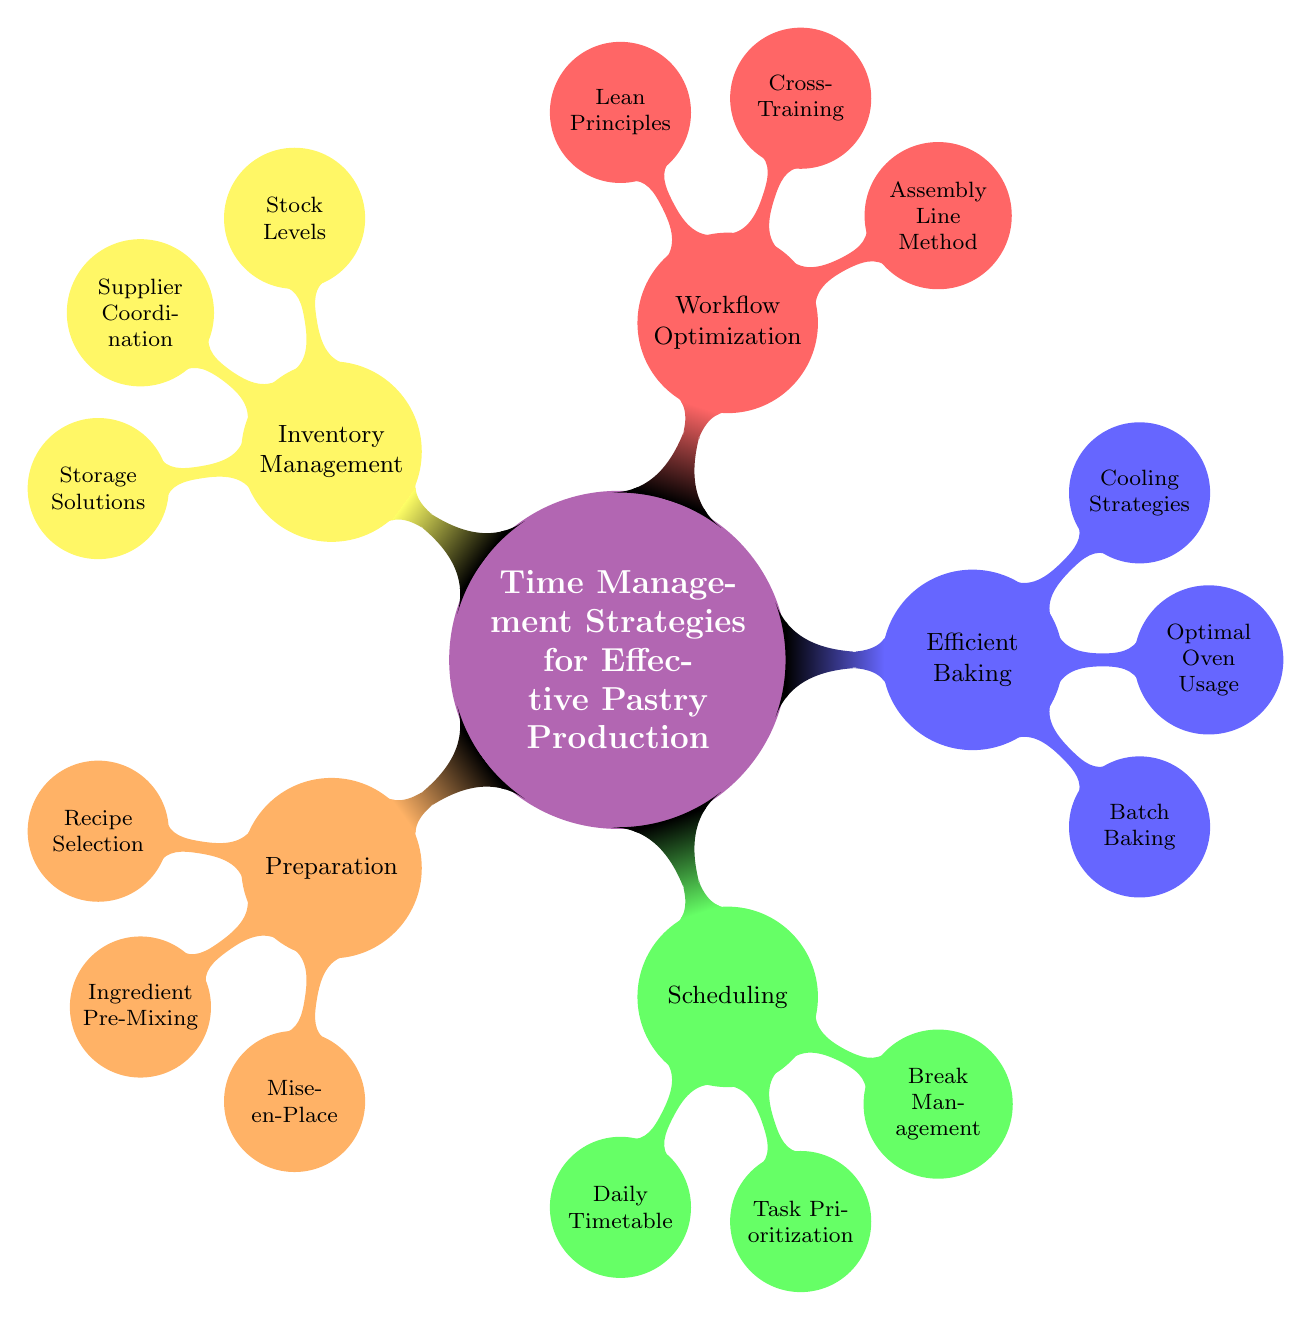What's the total number of main categories in the diagram? The diagram contains five main categories: Preparation, Scheduling, Efficient Baking, Workflow Optimization, and Inventory Management. By counting the main nodes branching out from the central node, we determine that there are five.
Answer: 5 Which category includes 'Batch Baking'? 'Batch Baking' is found under the 'Efficient Baking' category, as indicated by its position within that segment of the mind map.
Answer: Efficient Baking What strategy is suggested for 'Ingredient Pre-Mixing'? The strategy for 'Ingredient Pre-Mixing' is to batch prepare dry ingredients, as labeled in the relevant node in the mind map.
Answer: Batch prepare dry ingredients Which two categories focus on optimizing processes within pastry production? The two categories that emphasize process optimization are 'Workflow Optimization' and 'Efficient Baking', as they both include strategies aimed at enhancing production efficiency.
Answer: Workflow Optimization and Efficient Baking How many nodes are there under 'Inventory Management'? Under 'Inventory Management', there are three nodes: Stock Levels, Supplier Coordination, and Storage Solutions. By counting these, we find three nodes.
Answer: 3 What is the main focus of the 'Assembly Line Method'? The 'Assembly Line Method' focuses on streamlining tasks using assembly line techniques, which is specifically highlighted in its node.
Answer: Streamline tasks using assembly line techniques Which strategy entails monitoring stock levels? The strategy concerning monitoring stock levels is labeled 'Stock Levels' under the 'Inventory Management' category, indicating its importance in inventory control.
Answer: Stock Levels What is the purpose of 'Cross-Training' in this diagram? 'Cross-Training' serves the purpose of training staff in multiple roles to cover absences, as specified in the node detailing its strategy within 'Workflow Optimization'.
Answer: Train staff in multiple roles to cover absences How does 'Break Management' relate to scheduling? 'Break Management' is related to scheduling by allocating break times to avoid burnout, demonstrating its critical role in maintaining productivity during work hours.
Answer: Allocate break times to avoid burnout 